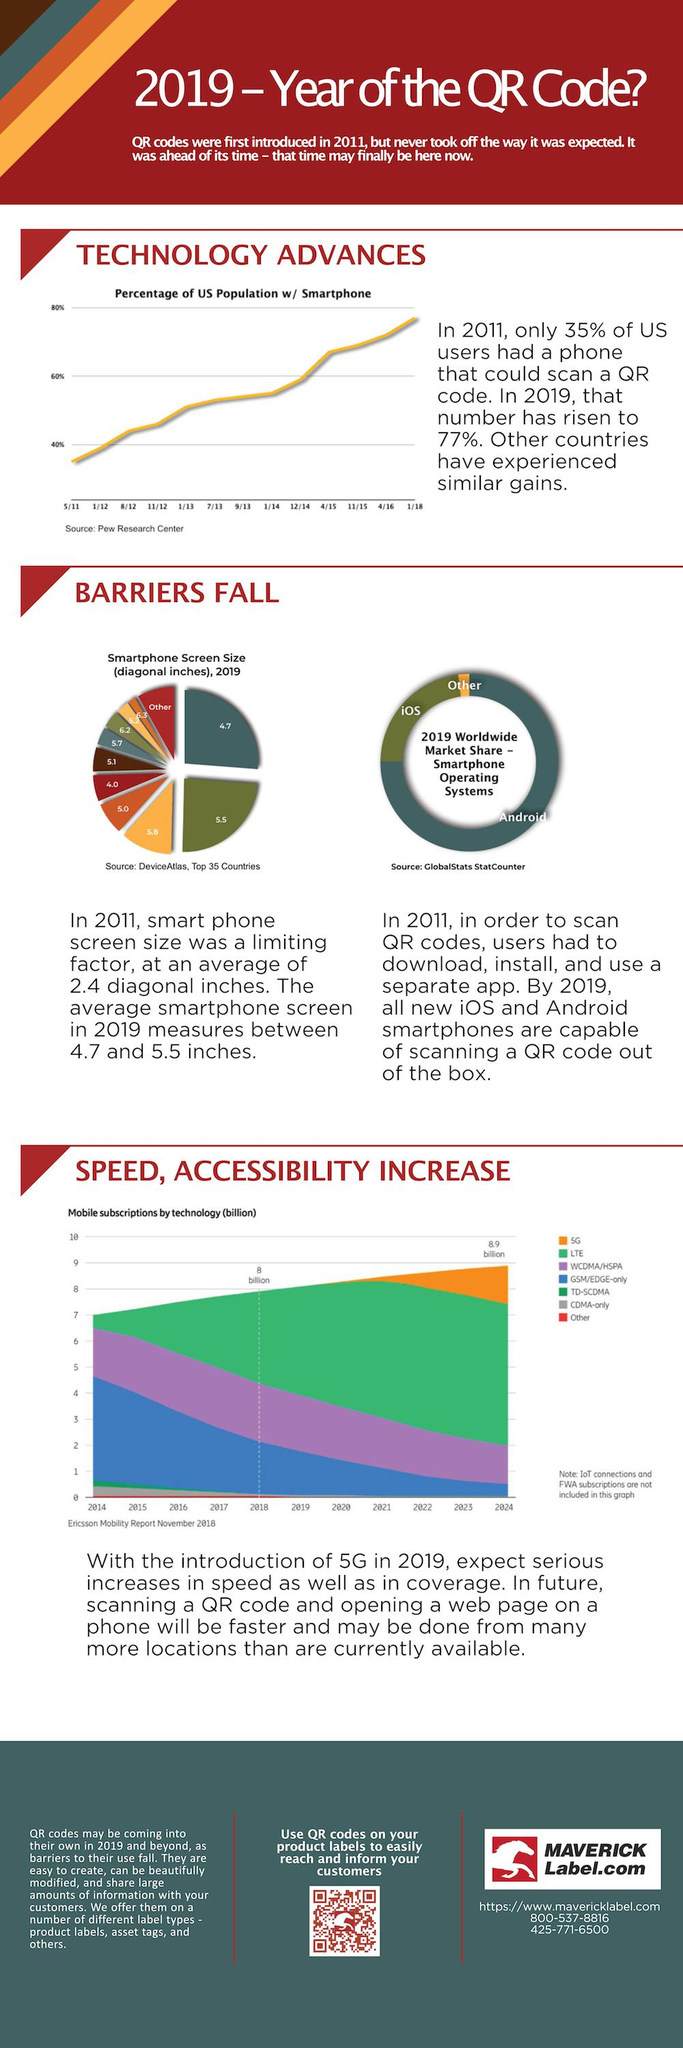Indicate a few pertinent items in this graphic. As of 2018, LTE had reached a total of 8 billion subscriptions worldwide. iOS is the second most widely used smartphone operating system. There are 7 types of subscriptions plotted on the graph. The percentage of increase in smart phone users from 2011 to 2019 in the U.S. was 42%. LTE is the most widely used mobile technology. 